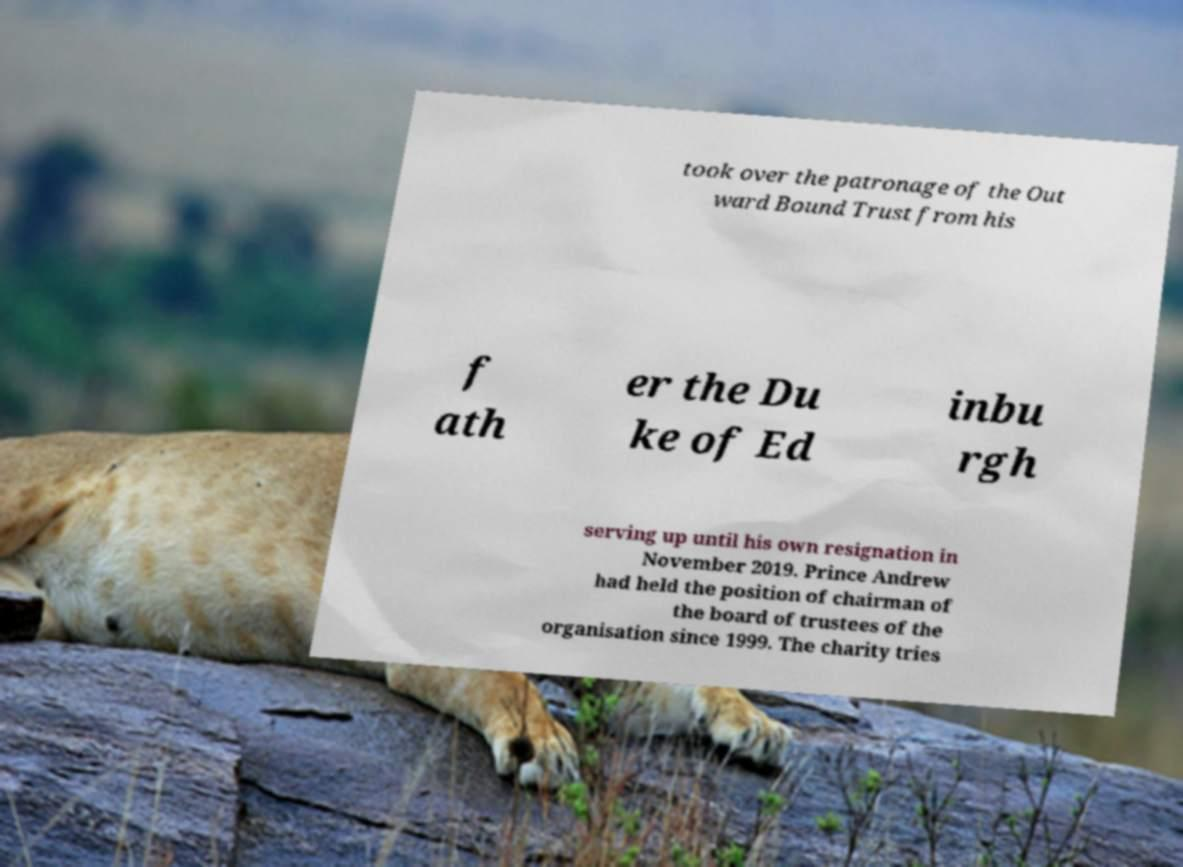Please read and relay the text visible in this image. What does it say? took over the patronage of the Out ward Bound Trust from his f ath er the Du ke of Ed inbu rgh serving up until his own resignation in November 2019. Prince Andrew had held the position of chairman of the board of trustees of the organisation since 1999. The charity tries 